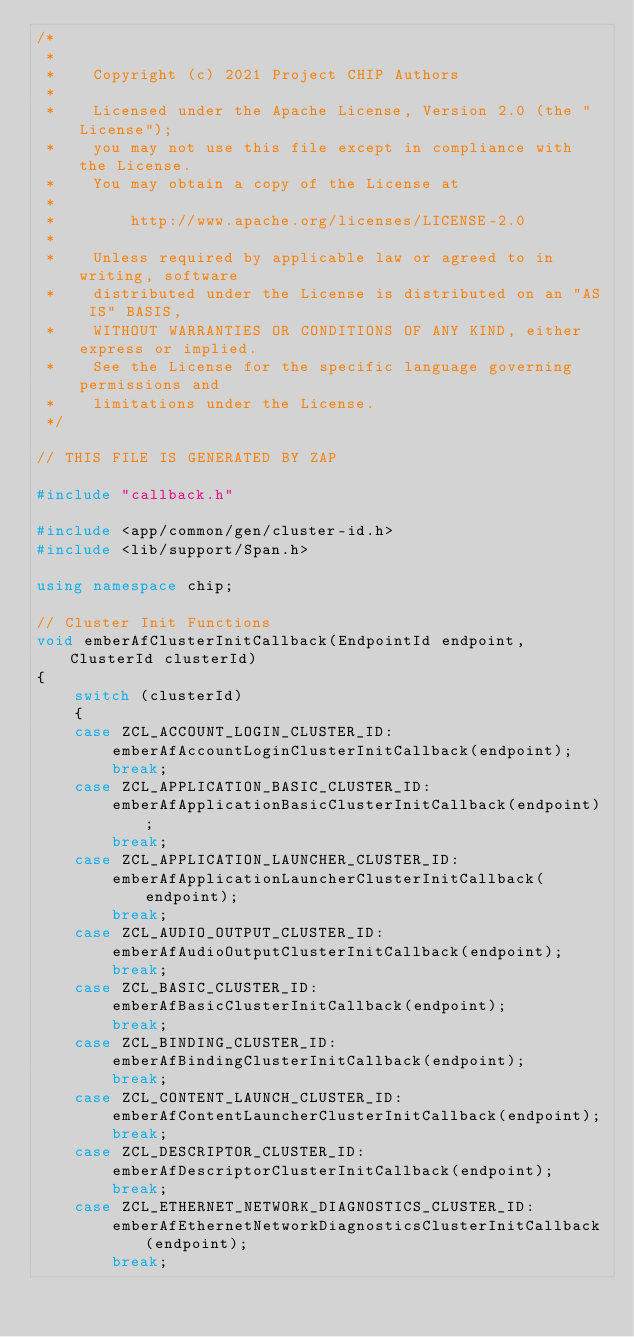Convert code to text. <code><loc_0><loc_0><loc_500><loc_500><_C++_>/*
 *
 *    Copyright (c) 2021 Project CHIP Authors
 *
 *    Licensed under the Apache License, Version 2.0 (the "License");
 *    you may not use this file except in compliance with the License.
 *    You may obtain a copy of the License at
 *
 *        http://www.apache.org/licenses/LICENSE-2.0
 *
 *    Unless required by applicable law or agreed to in writing, software
 *    distributed under the License is distributed on an "AS IS" BASIS,
 *    WITHOUT WARRANTIES OR CONDITIONS OF ANY KIND, either express or implied.
 *    See the License for the specific language governing permissions and
 *    limitations under the License.
 */

// THIS FILE IS GENERATED BY ZAP

#include "callback.h"

#include <app/common/gen/cluster-id.h>
#include <lib/support/Span.h>

using namespace chip;

// Cluster Init Functions
void emberAfClusterInitCallback(EndpointId endpoint, ClusterId clusterId)
{
    switch (clusterId)
    {
    case ZCL_ACCOUNT_LOGIN_CLUSTER_ID:
        emberAfAccountLoginClusterInitCallback(endpoint);
        break;
    case ZCL_APPLICATION_BASIC_CLUSTER_ID:
        emberAfApplicationBasicClusterInitCallback(endpoint);
        break;
    case ZCL_APPLICATION_LAUNCHER_CLUSTER_ID:
        emberAfApplicationLauncherClusterInitCallback(endpoint);
        break;
    case ZCL_AUDIO_OUTPUT_CLUSTER_ID:
        emberAfAudioOutputClusterInitCallback(endpoint);
        break;
    case ZCL_BASIC_CLUSTER_ID:
        emberAfBasicClusterInitCallback(endpoint);
        break;
    case ZCL_BINDING_CLUSTER_ID:
        emberAfBindingClusterInitCallback(endpoint);
        break;
    case ZCL_CONTENT_LAUNCH_CLUSTER_ID:
        emberAfContentLauncherClusterInitCallback(endpoint);
        break;
    case ZCL_DESCRIPTOR_CLUSTER_ID:
        emberAfDescriptorClusterInitCallback(endpoint);
        break;
    case ZCL_ETHERNET_NETWORK_DIAGNOSTICS_CLUSTER_ID:
        emberAfEthernetNetworkDiagnosticsClusterInitCallback(endpoint);
        break;</code> 